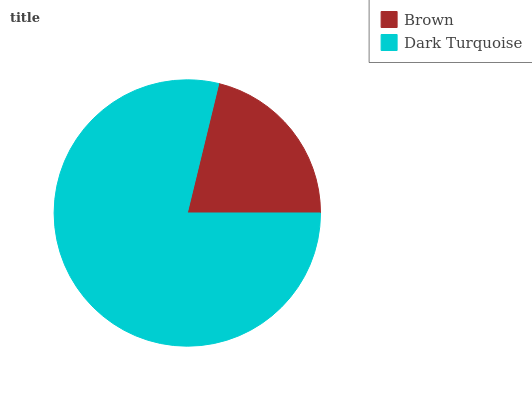Is Brown the minimum?
Answer yes or no. Yes. Is Dark Turquoise the maximum?
Answer yes or no. Yes. Is Dark Turquoise the minimum?
Answer yes or no. No. Is Dark Turquoise greater than Brown?
Answer yes or no. Yes. Is Brown less than Dark Turquoise?
Answer yes or no. Yes. Is Brown greater than Dark Turquoise?
Answer yes or no. No. Is Dark Turquoise less than Brown?
Answer yes or no. No. Is Dark Turquoise the high median?
Answer yes or no. Yes. Is Brown the low median?
Answer yes or no. Yes. Is Brown the high median?
Answer yes or no. No. Is Dark Turquoise the low median?
Answer yes or no. No. 